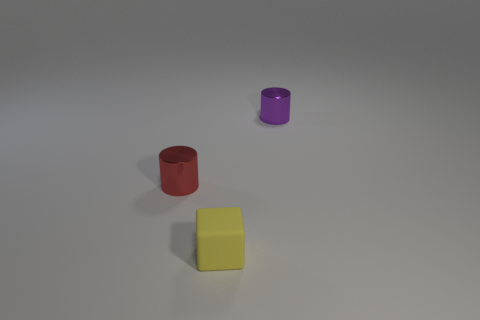Add 3 big brown spheres. How many objects exist? 6 Subtract all blocks. How many objects are left? 2 Add 2 purple balls. How many purple balls exist? 2 Subtract 0 brown cylinders. How many objects are left? 3 Subtract all small red objects. Subtract all tiny metal cylinders. How many objects are left? 0 Add 1 tiny yellow objects. How many tiny yellow objects are left? 2 